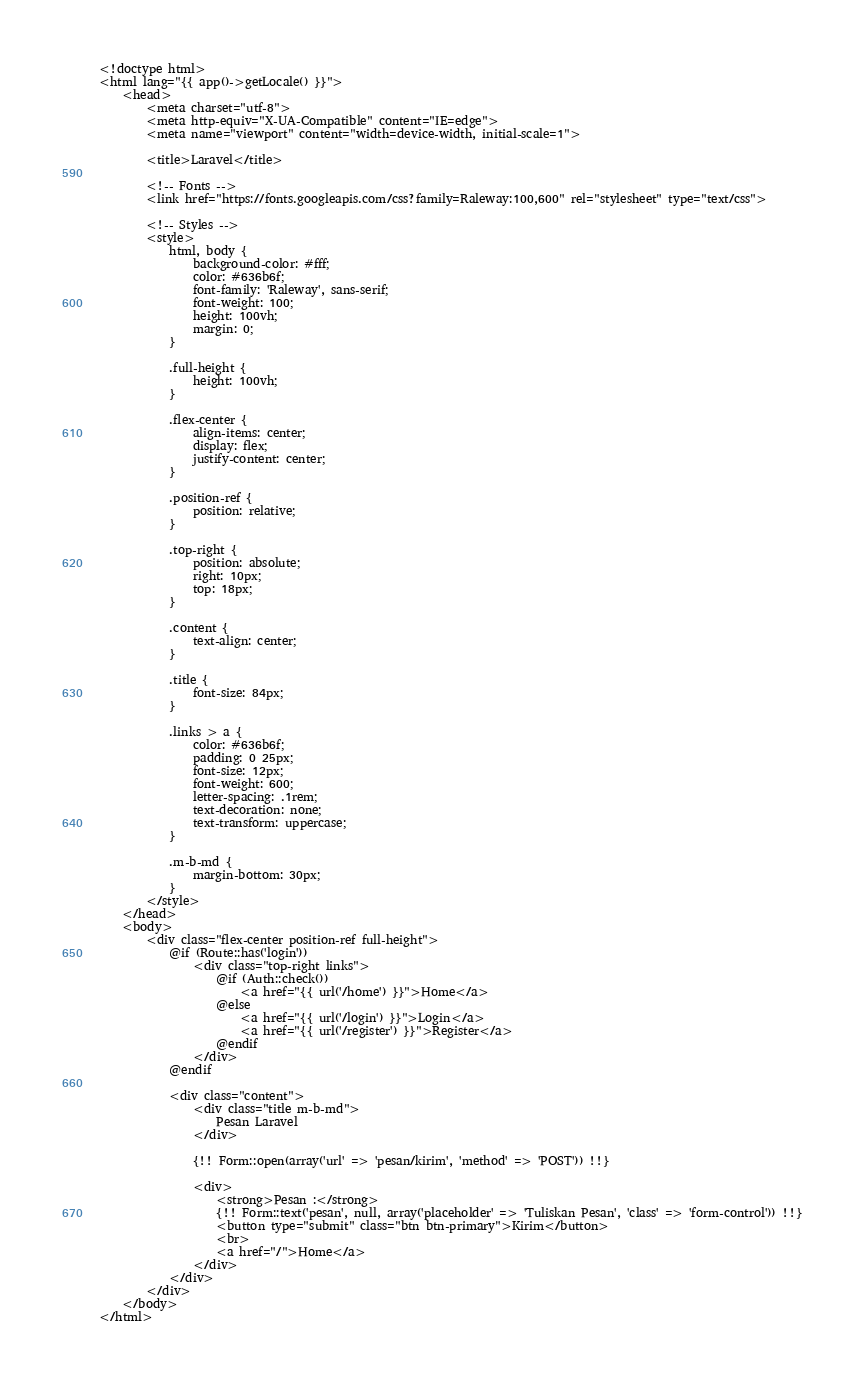<code> <loc_0><loc_0><loc_500><loc_500><_PHP_><!doctype html>
<html lang="{{ app()->getLocale() }}">
    <head>
        <meta charset="utf-8">
        <meta http-equiv="X-UA-Compatible" content="IE=edge">
        <meta name="viewport" content="width=device-width, initial-scale=1">

        <title>Laravel</title>

        <!-- Fonts -->
        <link href="https://fonts.googleapis.com/css?family=Raleway:100,600" rel="stylesheet" type="text/css">

        <!-- Styles -->
        <style>
            html, body {
                background-color: #fff;
                color: #636b6f;
                font-family: 'Raleway', sans-serif;
                font-weight: 100;
                height: 100vh;
                margin: 0;
            }

            .full-height {
                height: 100vh;
            }

            .flex-center {
                align-items: center;
                display: flex;
                justify-content: center;
            }

            .position-ref {
                position: relative;
            }

            .top-right {
                position: absolute;
                right: 10px;
                top: 18px;
            }

            .content {
                text-align: center;
            }

            .title {
                font-size: 84px;
            }

            .links > a {
                color: #636b6f;
                padding: 0 25px;
                font-size: 12px;
                font-weight: 600;
                letter-spacing: .1rem;
                text-decoration: none;
                text-transform: uppercase;
            }

            .m-b-md {
                margin-bottom: 30px;
            }
        </style>
    </head>
    <body>
        <div class="flex-center position-ref full-height">
            @if (Route::has('login'))
                <div class="top-right links">
                    @if (Auth::check())
                        <a href="{{ url('/home') }}">Home</a>
                    @else
                        <a href="{{ url('/login') }}">Login</a>
                        <a href="{{ url('/register') }}">Register</a>
                    @endif
                </div>
            @endif

            <div class="content">
                <div class="title m-b-md">
                    Pesan Laravel
                </div>
				
				{!! Form::open(array('url' => 'pesan/kirim', 'method' => 'POST')) !!}
				
                <div>
                    <strong>Pesan :</strong>
					{!! Form::text('pesan', null, array('placeholder' => 'Tuliskan Pesan', 'class' => 'form-control')) !!}
					<button type="submit" class="btn btn-primary">Kirim</button>
					<br>
					<a href="/">Home</a>
                </div>
            </div>
        </div>
    </body>
</html>
</code> 